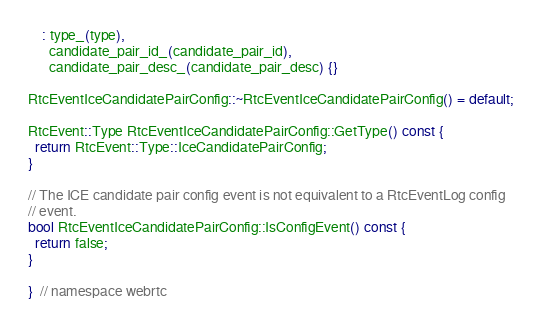Convert code to text. <code><loc_0><loc_0><loc_500><loc_500><_C++_>    : type_(type),
      candidate_pair_id_(candidate_pair_id),
      candidate_pair_desc_(candidate_pair_desc) {}

RtcEventIceCandidatePairConfig::~RtcEventIceCandidatePairConfig() = default;

RtcEvent::Type RtcEventIceCandidatePairConfig::GetType() const {
  return RtcEvent::Type::IceCandidatePairConfig;
}

// The ICE candidate pair config event is not equivalent to a RtcEventLog config
// event.
bool RtcEventIceCandidatePairConfig::IsConfigEvent() const {
  return false;
}

}  // namespace webrtc
</code> 